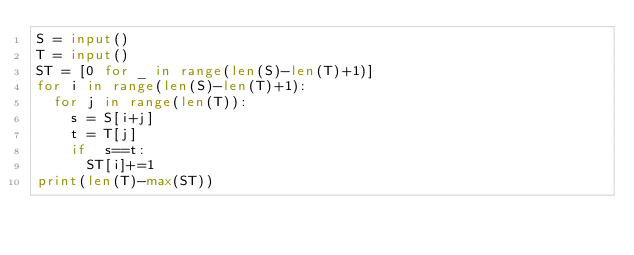<code> <loc_0><loc_0><loc_500><loc_500><_Python_>S = input()
T = input()
ST = [0 for _ in range(len(S)-len(T)+1)]
for i in range(len(S)-len(T)+1):
  for j in range(len(T)):
    s = S[i+j]
    t = T[j]
    if  s==t:
      ST[i]+=1
print(len(T)-max(ST))</code> 